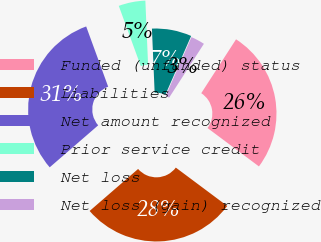Convert chart to OTSL. <chart><loc_0><loc_0><loc_500><loc_500><pie_chart><fcel>Funded (unfunded) status<fcel>Liabilities<fcel>Net amount recognized<fcel>Prior service credit<fcel>Net loss<fcel>Net loss (gain) recognized<nl><fcel>26.08%<fcel>28.43%<fcel>30.79%<fcel>4.9%<fcel>7.25%<fcel>2.55%<nl></chart> 